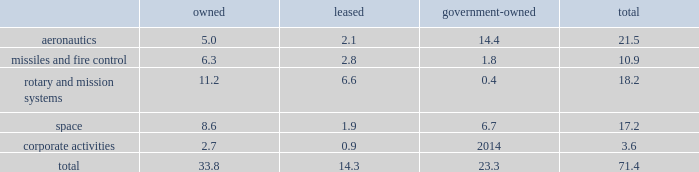Item 2 .
Properties at december 31 , 2017 , we owned or leased building space ( including offices , manufacturing plants , warehouses , service centers , laboratories and other facilities ) at approximately 375 locations primarily in the u.s .
Additionally , we manage or occupy approximately 15 government-owned facilities under lease and other arrangements .
At december 31 , 2017 , we had significant operations in the following locations : 2022 aeronautics - palmdale , california ; marietta , georgia ; greenville , south carolina ; and fort worth , texas .
2022 missiles and fire control - camdenarkansas ; ocala and orlando , florida ; lexington , kentucky ; and grand prairie , texas .
2022 rotary andmission systems - colorado springs , colorado ; shelton and stratford , connecticut ; orlando and jupiter , florida ; moorestown/mt .
Laurel , new jersey ; owego and syracuse , new york ; manassas , virginia ; and mielec , poland .
2022 space - sunnyvale , california ; denver , colorado ; valley forge , pennsylvania ; and reading , england .
2022 corporate activities - bethesda , maryland .
The following is a summary of our square feet of floor space by business segment at december 31 , 2017 ( in millions ) : owned leased government- owned total .
We believe our facilities are in good condition and adequate for their current use.wemay improve , replace or reduce facilities as considered appropriate to meet the needs of our operations .
Item 3 .
Legal proceedings we are a party to or have property subject to litigation and other proceedings that arise in the ordinary course of our business , including matters arising under provisions relating to the protection of the environment and are subject to contingencies related to certain businesses we previously owned .
These types of matters could result in fines , penalties , compensatory or treble damages or non-monetary sanctions or relief .
We believe the probability is remote that the outcome of each of these matters will have a material adverse effect on the corporation as a whole , notwithstanding that the unfavorable resolution of any matter may have a material effect on our net earnings in any particular interim reporting period .
We cannot predict the outcome of legal or other proceedings with certainty .
These matters include the proceedings summarized in 201cnote 14 2013 legal proceedings , commitments and contingencies 201d included in our notes to consolidated financial statements .
We are subject to federal , state , local and foreign requirements for protection of the environment , including those for discharge ofhazardousmaterials and remediationof contaminated sites.due inpart to thecomplexity andpervasivenessof these requirements , we are a party to or have property subject to various lawsuits , proceedings and remediation obligations .
The extent of our financial exposure cannot in all cases be reasonably estimated at this time .
For information regarding these matters , including current estimates of the amounts that we believe are required for remediation or clean-up to the extent estimable , see 201ccriticalaccounting policies - environmental matters 201d in management 2019s discussion and analysis of financial condition and results of operations and 201cnote 14 2013 legal proceedings , commitments andcontingencies 201d included in ournotes to consolidated financial statements .
As a u.s .
Government contractor , we are subject to various audits and investigations by the u.s .
Government to determine whetherouroperations arebeingconducted in accordancewith applicable regulatory requirements.u.s.government investigations of us , whether relating to government contracts or conducted for other reasons , could result in administrative , civil , or criminal liabilities , including repayments , fines or penalties being imposed upon us , suspension , proposed debarment , debarment from eligibility for future u.s .
Government contracting , or suspension of export privileges .
Suspension or debarment could have a material adverse effect on us because of our dependence on contracts with the u.s .
Government .
U.s .
Government investigations often take years to complete and many result in no adverse action against us .
We also provide products and services to customers outside of the u.s. , which are subject to u.s .
And foreign laws and regulations and foreign procurement policies and practices .
Our compliance with local regulations or applicable u.s .
Government regulations also may be audited or investigated .
Item 4 .
Mine safety disclosures not applicable. .
At december 31 , 2017 what was the percent of the total owned square feet applicable to aeronautics 5.0? 
Computations: (5.0 / 33.8)
Answer: 0.14793. 